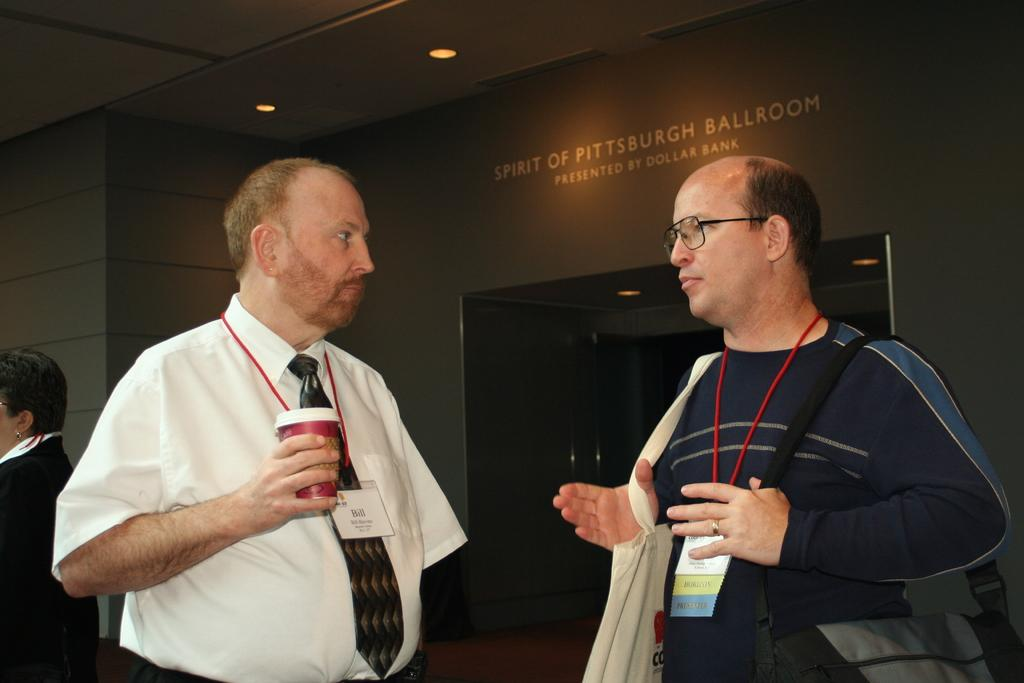What are the two men in the image doing? The two men in the image are standing and talking. Can you describe the attire of one of the men? One man is wearing a shirt, tie, and ID card. What type of lighting is present in the image? There are ceiling lights visible in the image. How many giants can be seen rolling in the image? There are no giants or rolling actions present in the image. 